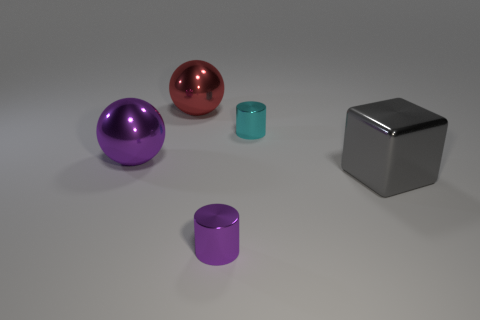Add 1 big gray metal objects. How many objects exist? 6 Subtract all spheres. How many objects are left? 3 Subtract all big metal spheres. Subtract all cyan cylinders. How many objects are left? 2 Add 2 large objects. How many large objects are left? 5 Add 4 yellow rubber things. How many yellow rubber things exist? 4 Subtract 0 gray cylinders. How many objects are left? 5 